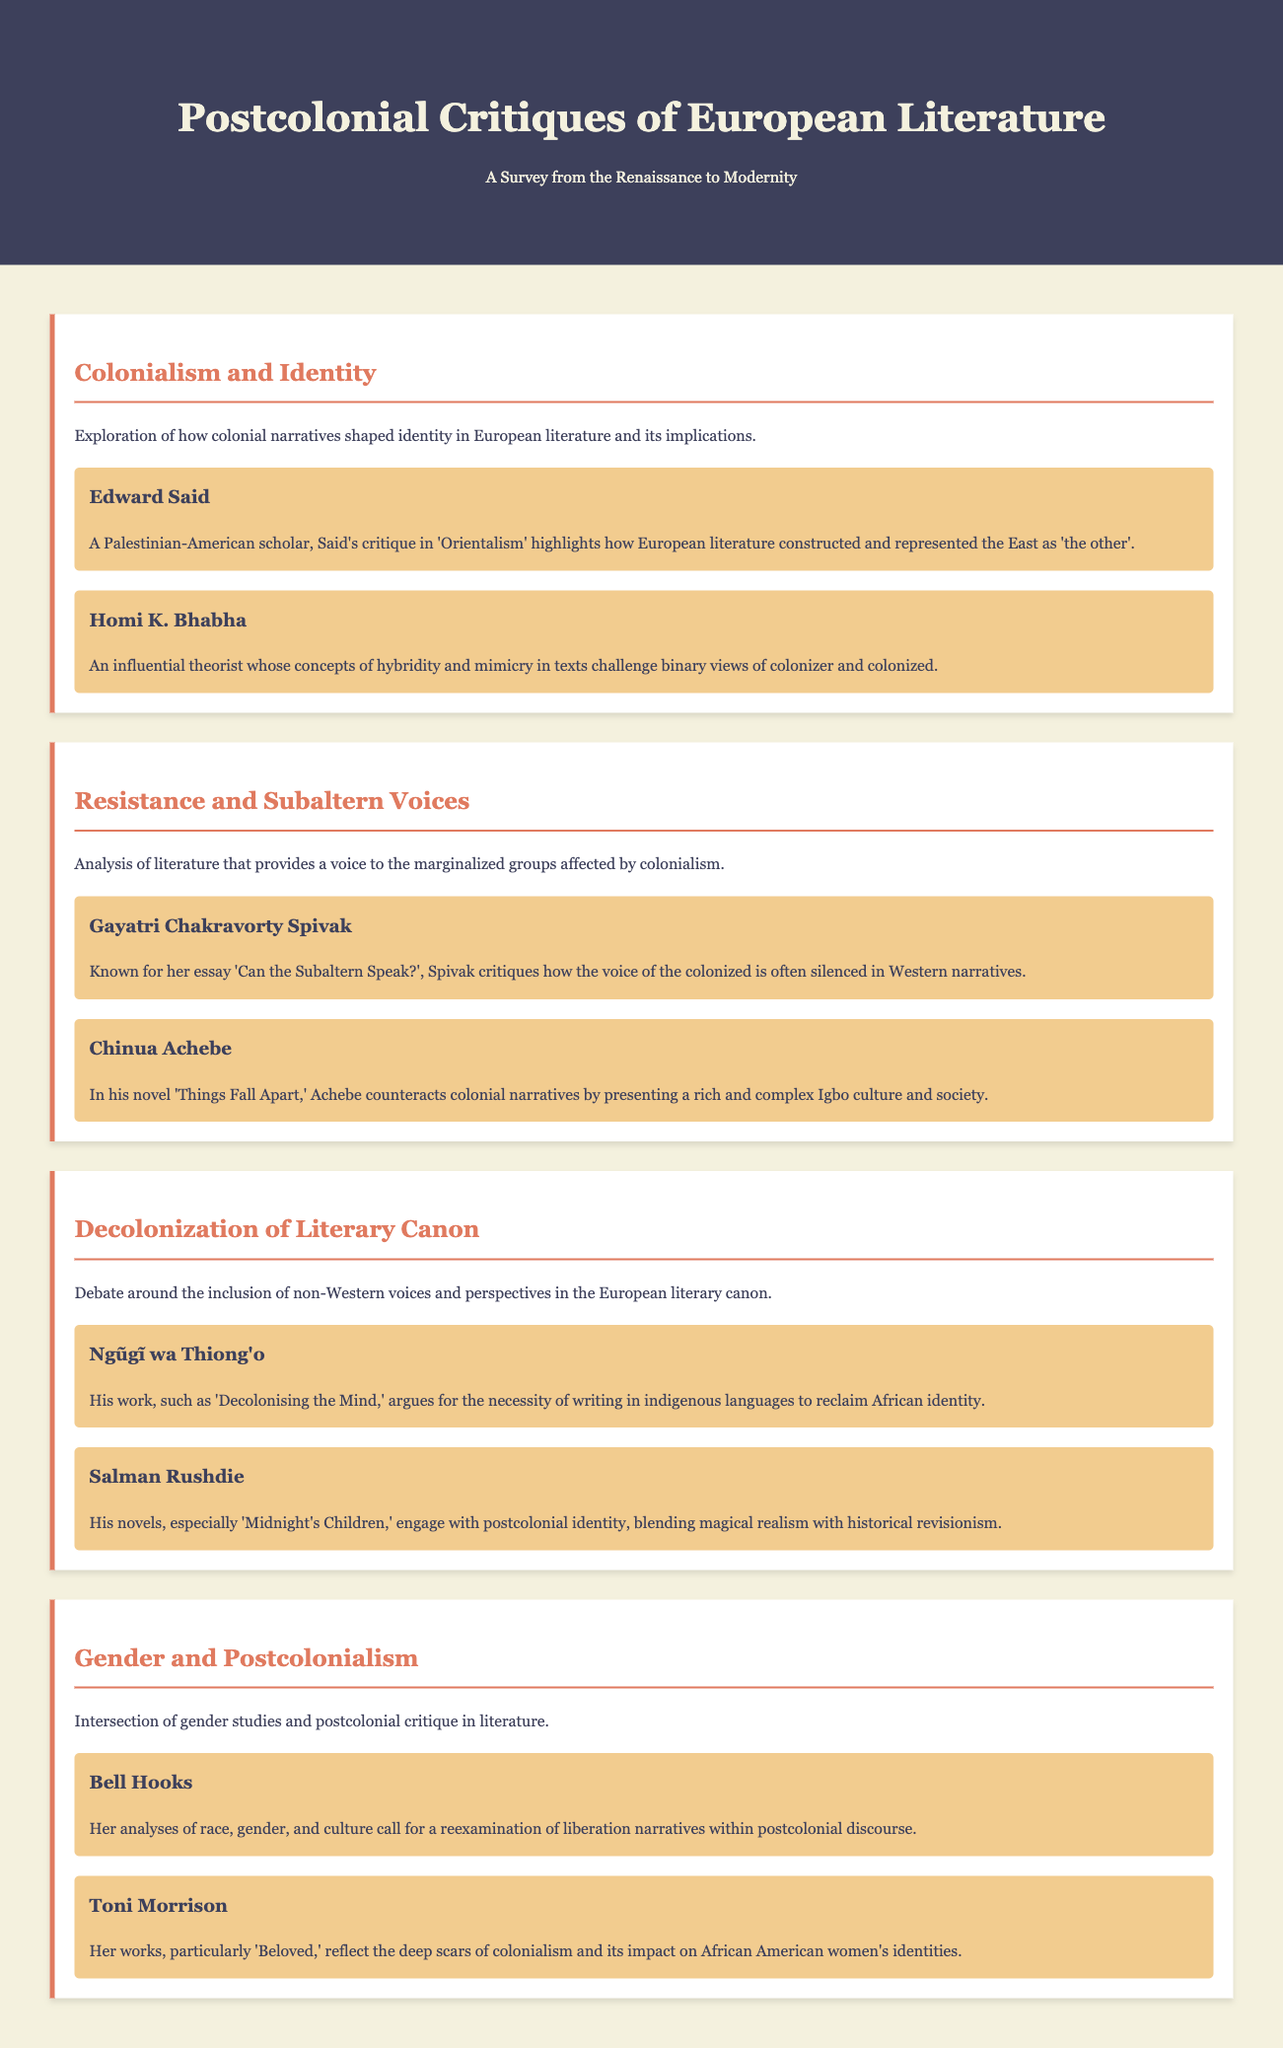what is the title of the document? The title of the document is stated in the header section, prominently displayed.
Answer: Postcolonial Critiques of European Literature who is the author of 'Orientalism'? Edward Said is identified as the author of 'Orientalism' in the section about Colonialism and Identity.
Answer: Edward Said which theorist is known for the concept of hybridity? The document explicitly mentions Homi K. Bhabha as the theorist known for the concept of hybridity.
Answer: Homi K. Bhabha what is the main theme of the section titled "Resistance and Subaltern Voices"? The main theme is described as literature that provides a voice to marginalized groups affected by colonialism.
Answer: Voice to marginalized groups who critiques how the voice of the colonized is often silenced? Gayatri Chakravorty Spivak is the scholar mentioned for this critique.
Answer: Gayatri Chakravorty Spivak in which work does Ngũgĩ wa Thiong'o argue for writing in indigenous languages? Ngũgĩ wa Thiong'o's argument is found in his work titled 'Decolonising the Mind.'
Answer: Decolonising the Mind which author’s works reflect the impact of colonialism on African American women's identities? Toni Morrison is noted for reflecting this impact in her works.
Answer: Toni Morrison what color is used for the section headers in the document? The document specifies that the color for section headers is a shade of reddish-orange.
Answer: Reddish-orange how many authors are featured in the theme "Gender and Postcolonialism"? The section on Gender and Postcolonialism features two authors.
Answer: Two 